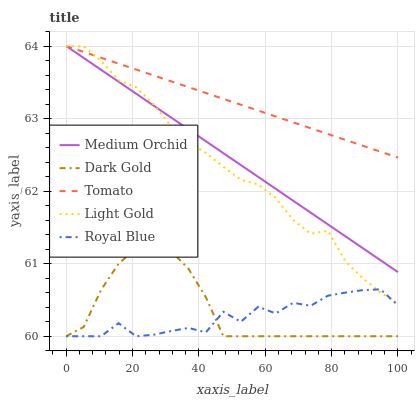Does Royal Blue have the minimum area under the curve?
Answer yes or no. Yes. Does Tomato have the maximum area under the curve?
Answer yes or no. Yes. Does Medium Orchid have the minimum area under the curve?
Answer yes or no. No. Does Medium Orchid have the maximum area under the curve?
Answer yes or no. No. Is Medium Orchid the smoothest?
Answer yes or no. Yes. Is Royal Blue the roughest?
Answer yes or no. Yes. Is Royal Blue the smoothest?
Answer yes or no. No. Is Medium Orchid the roughest?
Answer yes or no. No. Does Royal Blue have the lowest value?
Answer yes or no. Yes. Does Medium Orchid have the lowest value?
Answer yes or no. No. Does Light Gold have the highest value?
Answer yes or no. Yes. Does Royal Blue have the highest value?
Answer yes or no. No. Is Dark Gold less than Medium Orchid?
Answer yes or no. Yes. Is Tomato greater than Royal Blue?
Answer yes or no. Yes. Does Tomato intersect Medium Orchid?
Answer yes or no. Yes. Is Tomato less than Medium Orchid?
Answer yes or no. No. Is Tomato greater than Medium Orchid?
Answer yes or no. No. Does Dark Gold intersect Medium Orchid?
Answer yes or no. No. 